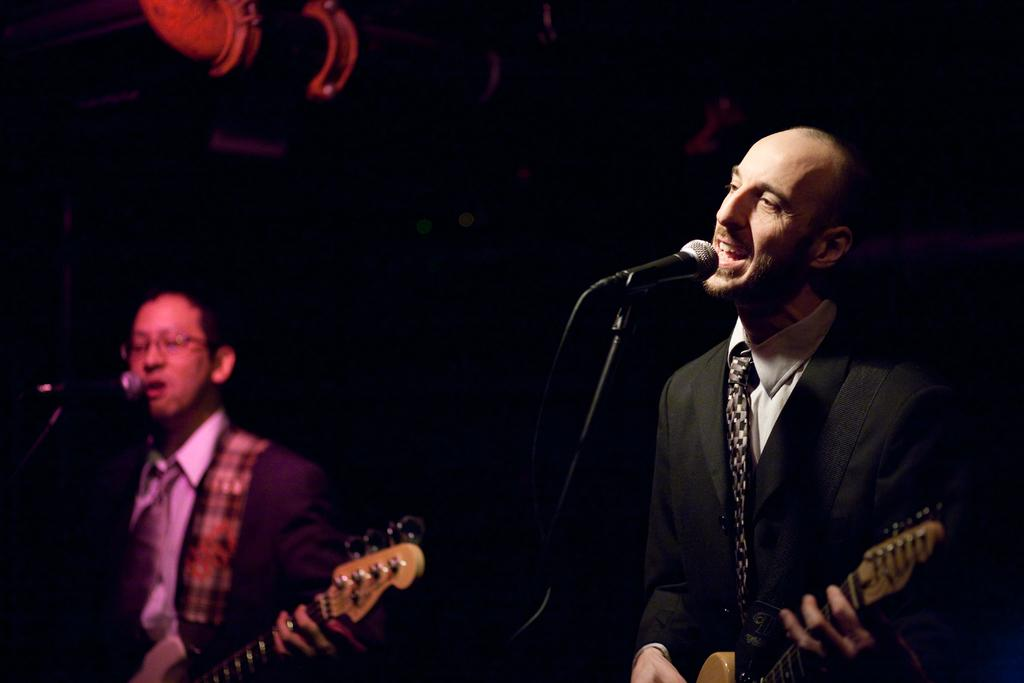How many men are in the image? There are two men in the image. What are the men wearing? Both men are wearing blazers and ties. What are the men holding in the image? The men are holding guitars. What are the men doing with the guitars? The men are playing the guitars. What else are the men doing in the image? The men are singing into microphones. What is the color of the background in the image? The background of the image is dark. What is the title of the song the men are singing in the image? There is no information about the title of the song the men are singing in the image. What view can be seen from the stage where the men are performing? There is no information about the view from the stage where the men are performing in the image. 